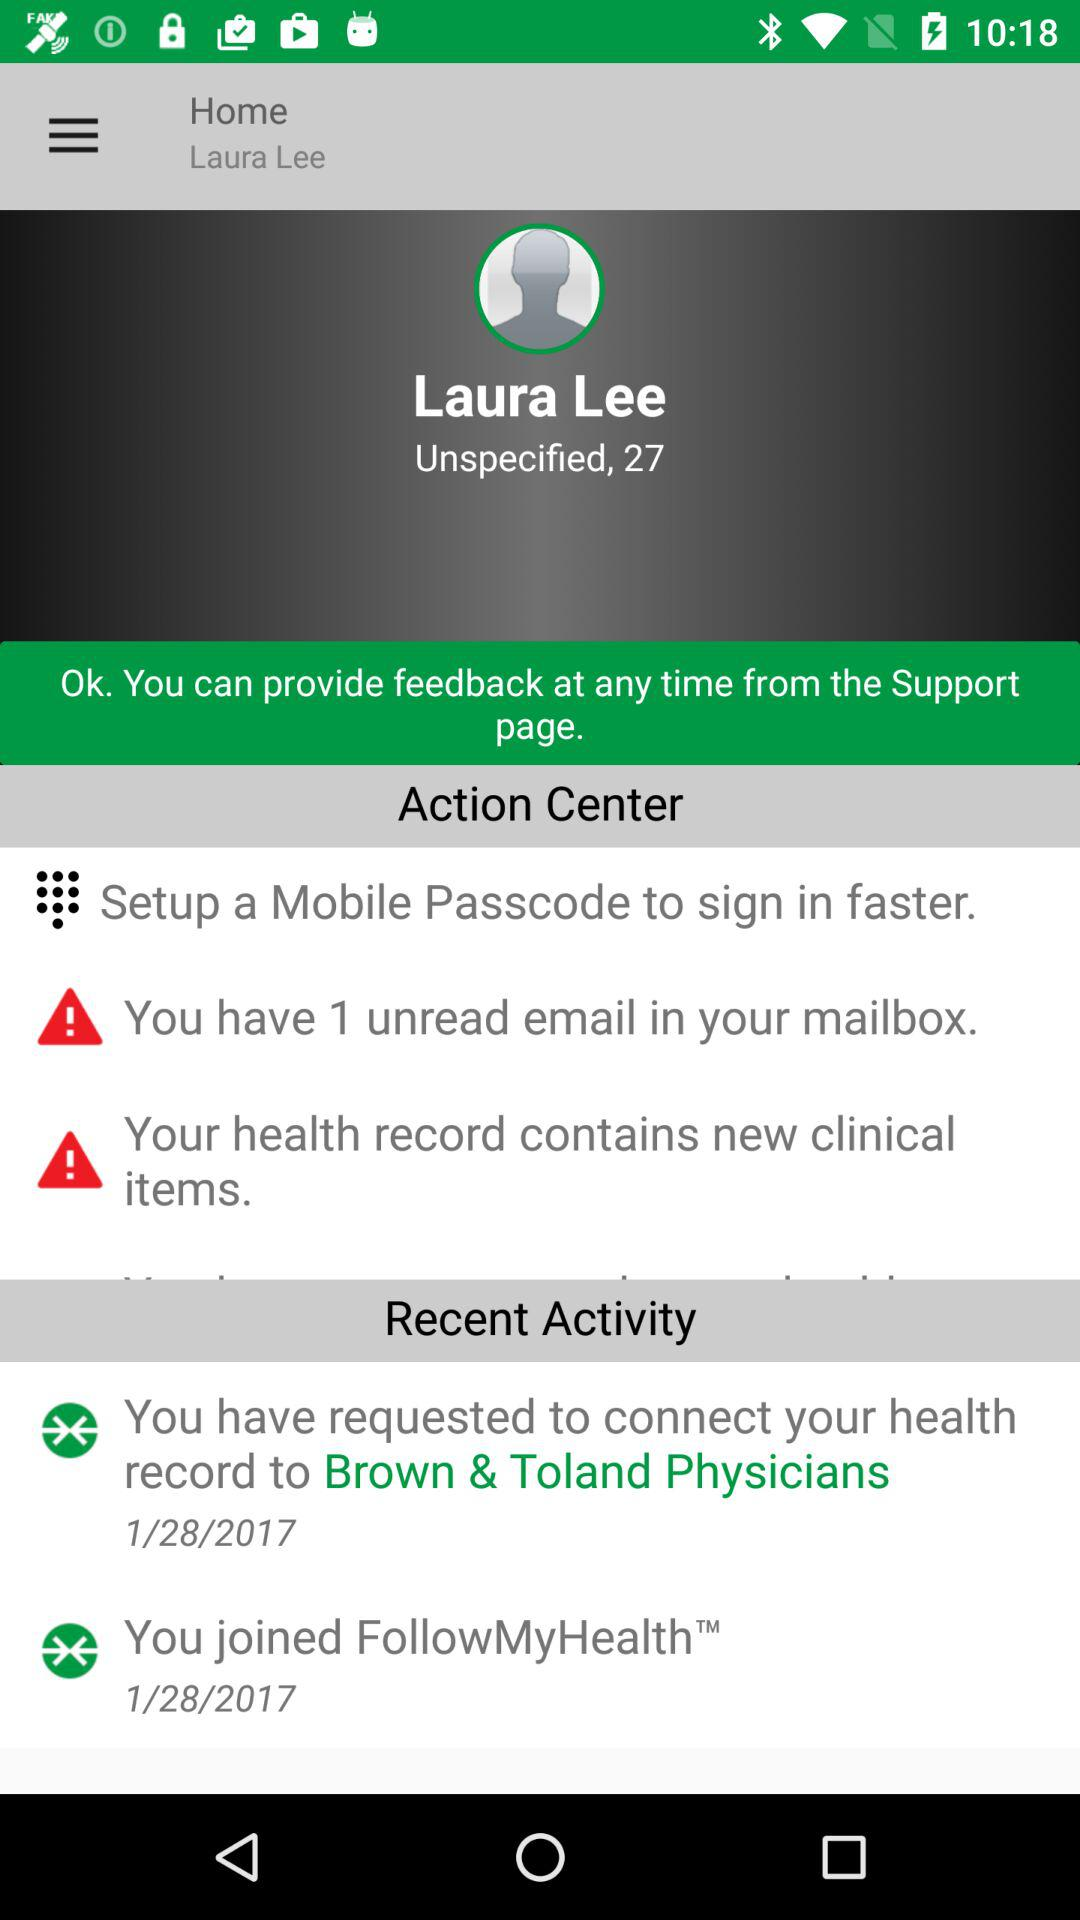How many unread emails are there in my mailbox? There is 1 unread email in your mailbox. 